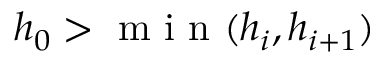<formula> <loc_0><loc_0><loc_500><loc_500>h _ { 0 } > \min ( h _ { i } , h _ { i + 1 } )</formula> 